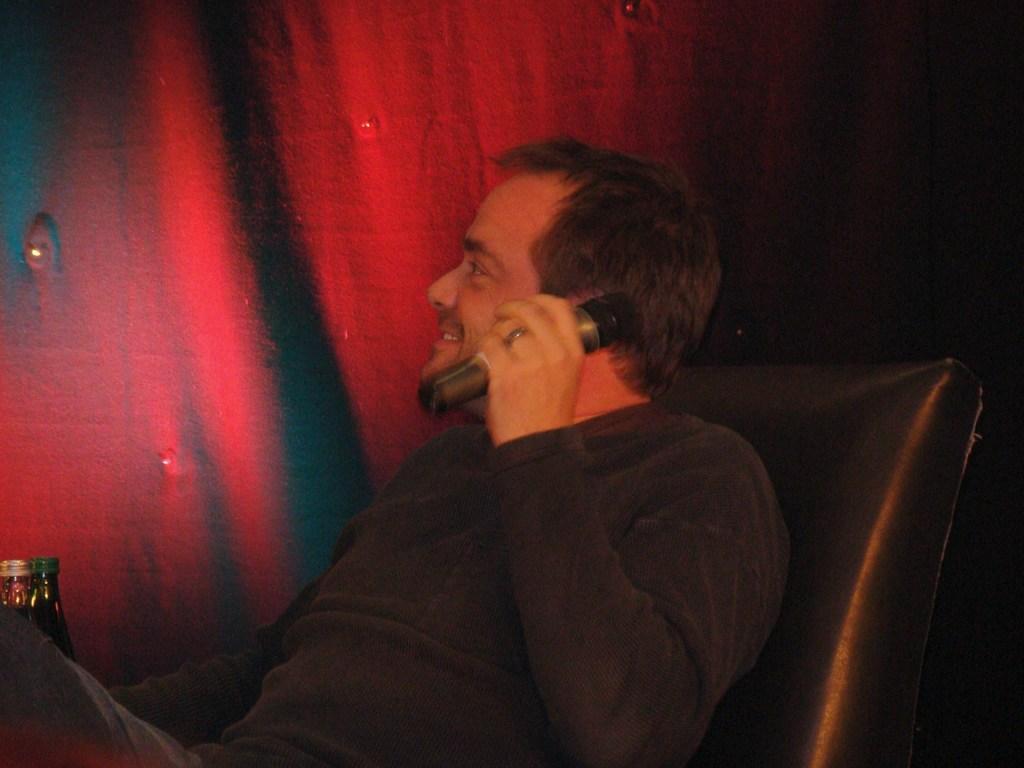Describe this image in one or two sentences. A person is sitting on a chair, holding a mic and is smiling. There are two bottles in the left. In the background there is a red curtain. 